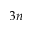<formula> <loc_0><loc_0><loc_500><loc_500>3 n</formula> 